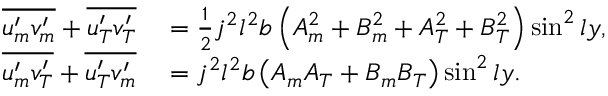<formula> <loc_0><loc_0><loc_500><loc_500>\begin{array} { r l } { \overline { { u _ { m } ^ { \prime } v _ { m } ^ { \prime } } } + \overline { { u _ { T } ^ { \prime } v _ { T } ^ { \prime } } } } & = \frac { 1 } { 2 } j ^ { 2 } l ^ { 2 } b \left ( { A _ { m } ^ { 2 } } + { B _ { m } ^ { 2 } } + { A _ { T } ^ { 2 } } + { B _ { T } ^ { 2 } } \right ) \sin ^ { 2 } l y , } \\ { \overline { { u _ { m } ^ { \prime } v _ { T } ^ { \prime } } } + \overline { { u _ { T } ^ { \prime } v _ { m } ^ { \prime } } } } & = j ^ { 2 } l ^ { 2 } b \left ( { A _ { m } A _ { T } } + { B _ { m } B _ { T } } \right ) \sin ^ { 2 } l y . } \end{array}</formula> 